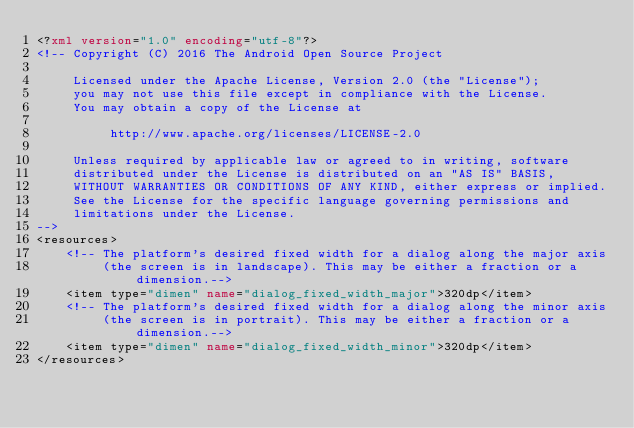<code> <loc_0><loc_0><loc_500><loc_500><_XML_><?xml version="1.0" encoding="utf-8"?>
<!-- Copyright (C) 2016 The Android Open Source Project

     Licensed under the Apache License, Version 2.0 (the "License");
     you may not use this file except in compliance with the License.
     You may obtain a copy of the License at

          http://www.apache.org/licenses/LICENSE-2.0

     Unless required by applicable law or agreed to in writing, software
     distributed under the License is distributed on an "AS IS" BASIS,
     WITHOUT WARRANTIES OR CONDITIONS OF ANY KIND, either express or implied.
     See the License for the specific language governing permissions and
     limitations under the License.
-->
<resources>
    <!-- The platform's desired fixed width for a dialog along the major axis
         (the screen is in landscape). This may be either a fraction or a dimension.-->
    <item type="dimen" name="dialog_fixed_width_major">320dp</item>
    <!-- The platform's desired fixed width for a dialog along the minor axis
         (the screen is in portrait). This may be either a fraction or a dimension.-->
    <item type="dimen" name="dialog_fixed_width_minor">320dp</item>
</resources>
</code> 